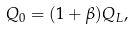Convert formula to latex. <formula><loc_0><loc_0><loc_500><loc_500>Q _ { 0 } = ( 1 + \beta ) Q _ { L } ,</formula> 